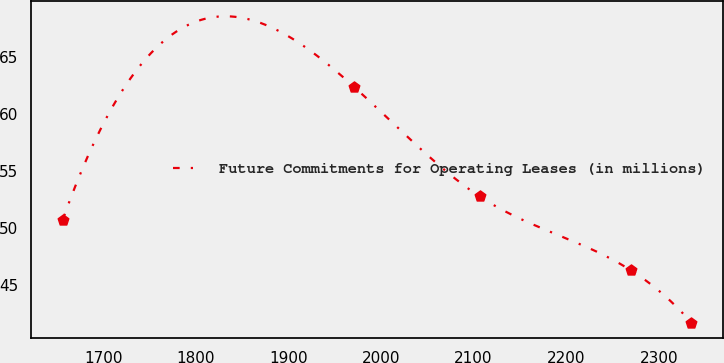Convert chart. <chart><loc_0><loc_0><loc_500><loc_500><line_chart><ecel><fcel>Future Commitments for Operating Leases (in millions)<nl><fcel>1656.2<fcel>50.71<nl><fcel>1970.68<fcel>62.41<nl><fcel>2106.57<fcel>52.78<nl><fcel>2269.96<fcel>46.3<nl><fcel>2335.18<fcel>41.71<nl></chart> 